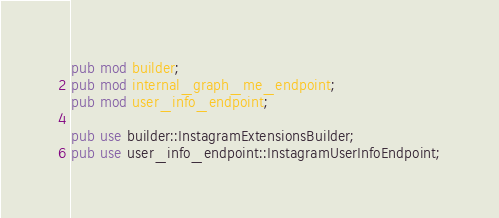<code> <loc_0><loc_0><loc_500><loc_500><_Rust_>pub mod builder;
pub mod internal_graph_me_endpoint;
pub mod user_info_endpoint;

pub use builder::InstagramExtensionsBuilder;
pub use user_info_endpoint::InstagramUserInfoEndpoint;
</code> 